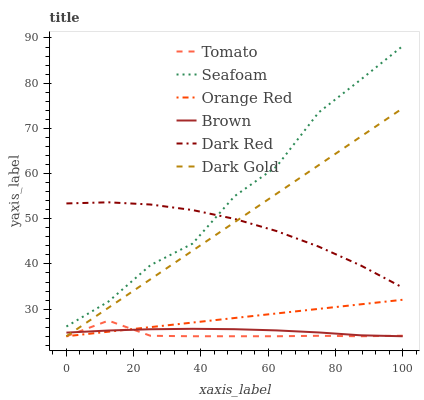Does Tomato have the minimum area under the curve?
Answer yes or no. Yes. Does Seafoam have the maximum area under the curve?
Answer yes or no. Yes. Does Brown have the minimum area under the curve?
Answer yes or no. No. Does Brown have the maximum area under the curve?
Answer yes or no. No. Is Orange Red the smoothest?
Answer yes or no. Yes. Is Seafoam the roughest?
Answer yes or no. Yes. Is Brown the smoothest?
Answer yes or no. No. Is Brown the roughest?
Answer yes or no. No. Does Dark Red have the lowest value?
Answer yes or no. No. Does Seafoam have the highest value?
Answer yes or no. Yes. Does Dark Gold have the highest value?
Answer yes or no. No. Is Dark Gold less than Seafoam?
Answer yes or no. Yes. Is Dark Red greater than Tomato?
Answer yes or no. Yes. Does Dark Gold intersect Dark Red?
Answer yes or no. Yes. Is Dark Gold less than Dark Red?
Answer yes or no. No. Is Dark Gold greater than Dark Red?
Answer yes or no. No. Does Dark Gold intersect Seafoam?
Answer yes or no. No. 